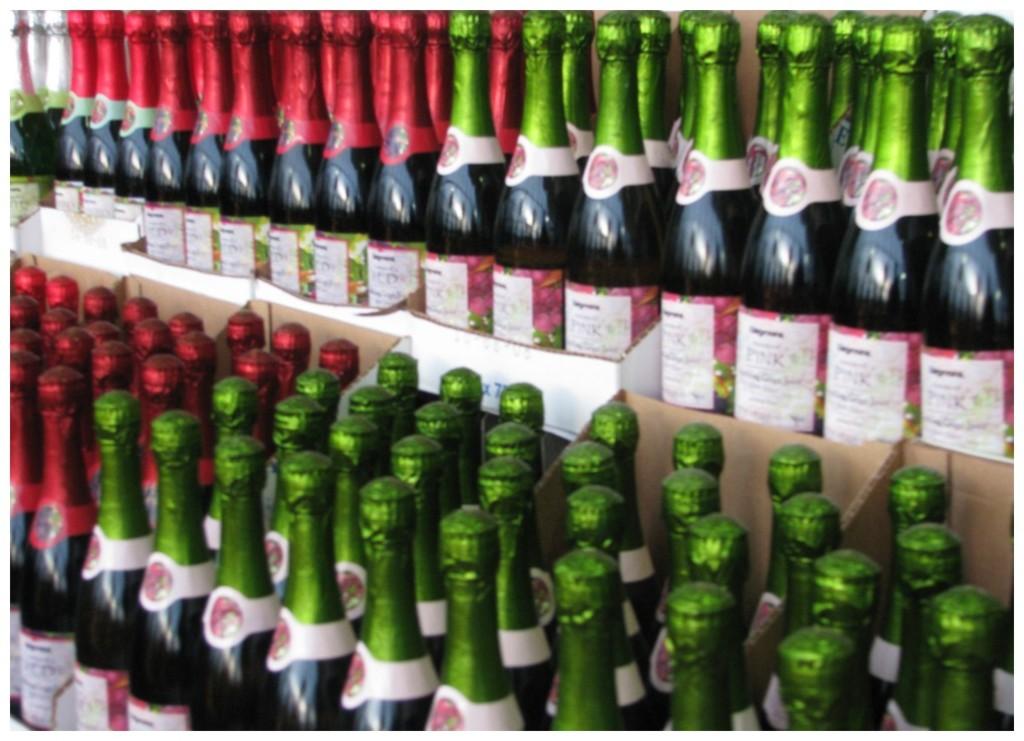What is the color written on the bottles?
Your answer should be very brief. Pink. 